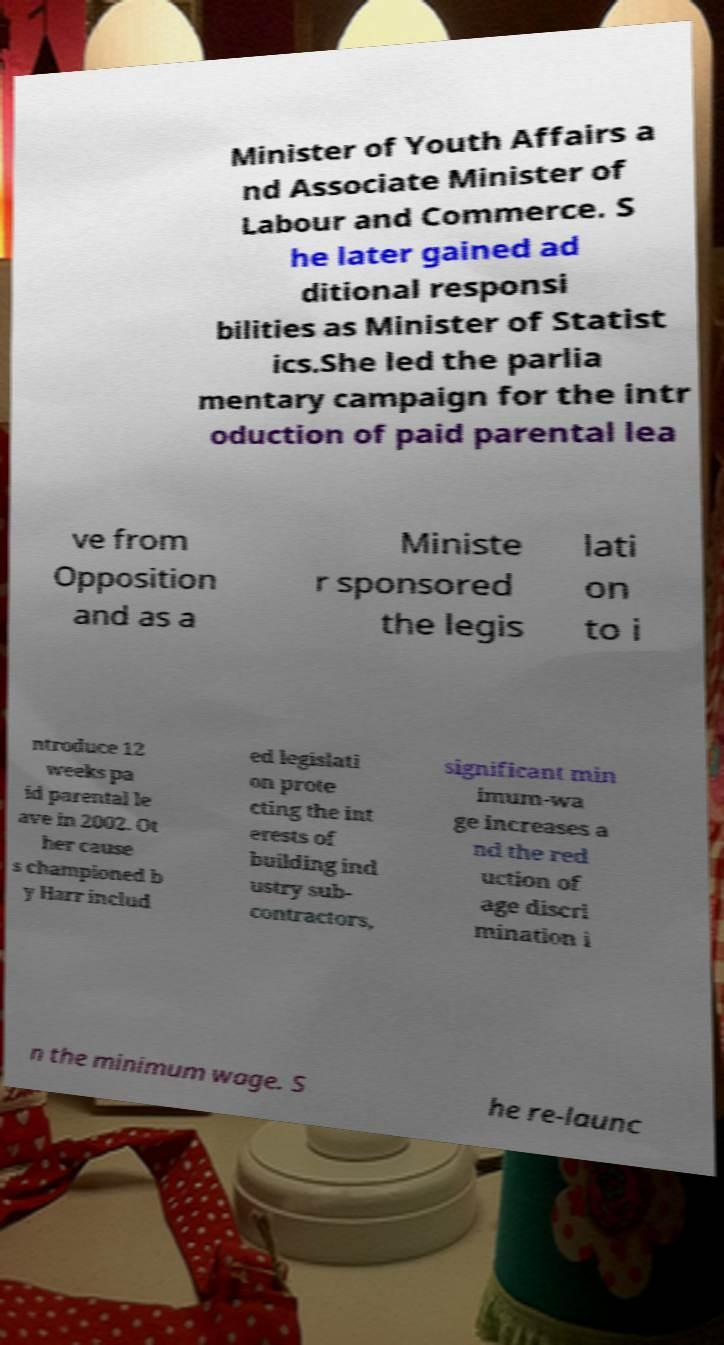I need the written content from this picture converted into text. Can you do that? Minister of Youth Affairs a nd Associate Minister of Labour and Commerce. S he later gained ad ditional responsi bilities as Minister of Statist ics.She led the parlia mentary campaign for the intr oduction of paid parental lea ve from Opposition and as a Ministe r sponsored the legis lati on to i ntroduce 12 weeks pa id parental le ave in 2002. Ot her cause s championed b y Harr includ ed legislati on prote cting the int erests of building ind ustry sub- contractors, significant min imum-wa ge increases a nd the red uction of age discri mination i n the minimum wage. S he re-launc 